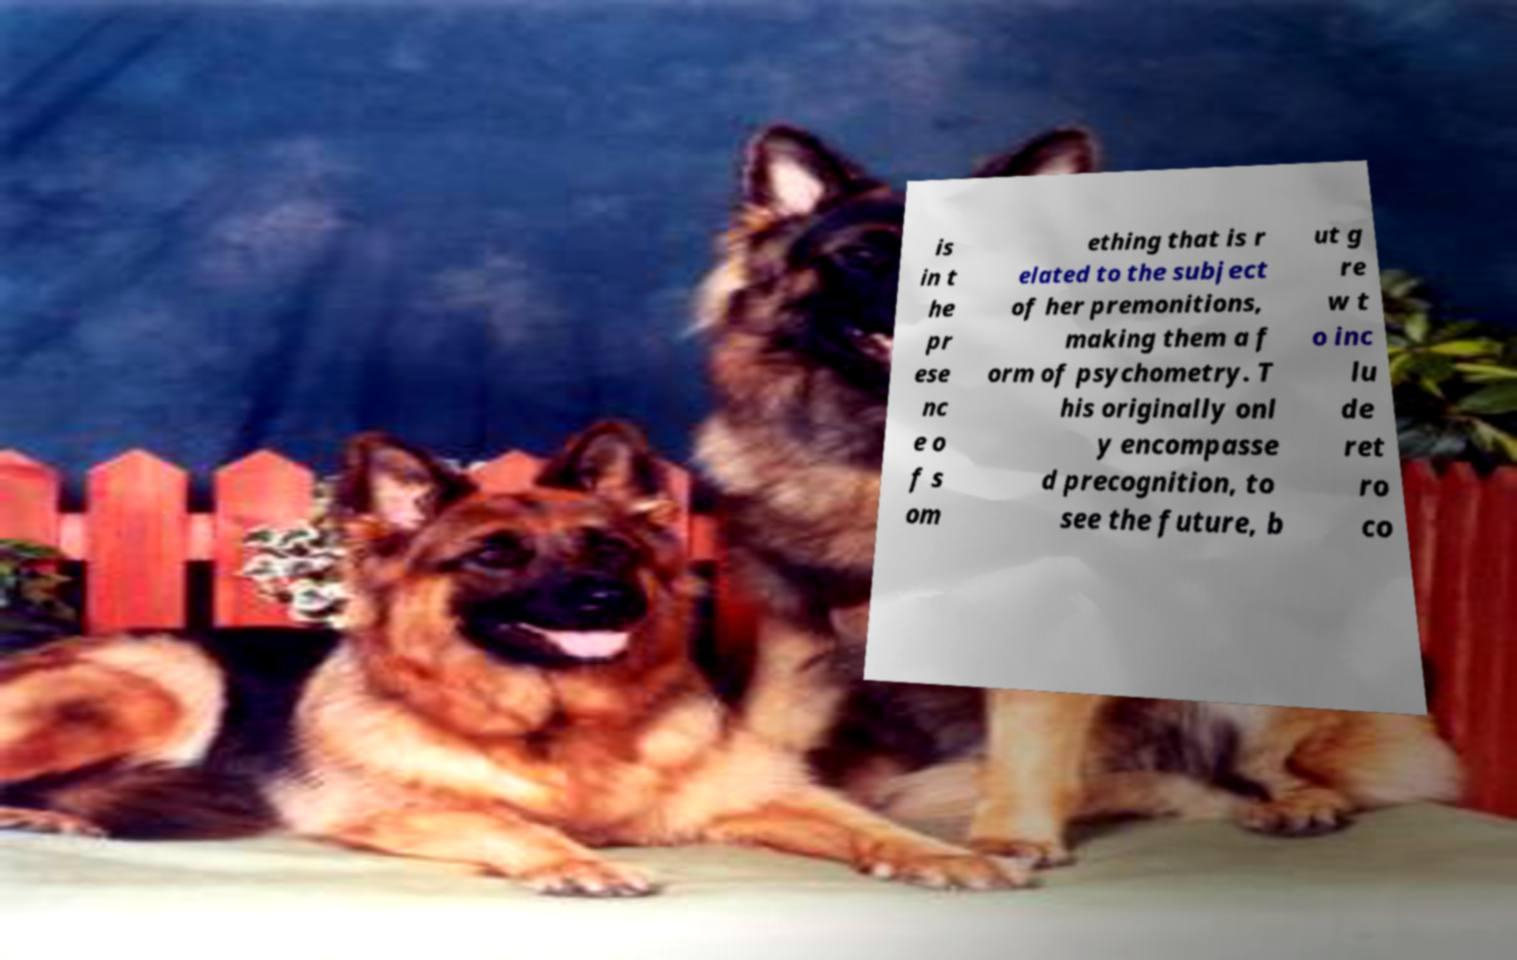Please read and relay the text visible in this image. What does it say? is in t he pr ese nc e o f s om ething that is r elated to the subject of her premonitions, making them a f orm of psychometry. T his originally onl y encompasse d precognition, to see the future, b ut g re w t o inc lu de ret ro co 